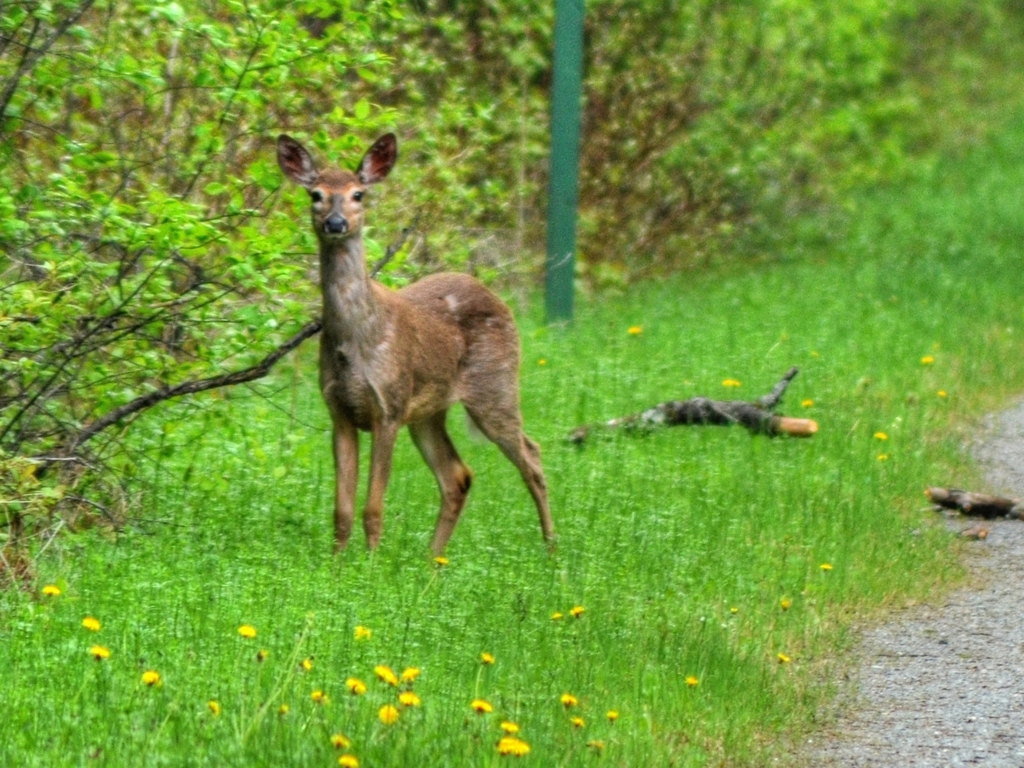Are there any quality issues with this image? The image appears to be somewhat blurry, which affects the overall sharpness and detail. Additionally, there is noticeable noise present, likely due to a high ISO setting or low light conditions when the photo was taken. This graininess reduces the quality of the picture. Moreover, the composition might be improved to focus more on the deer, which is the main subject. Despite these issues, the image captures a natural and candid moment in the wildlife setting. 